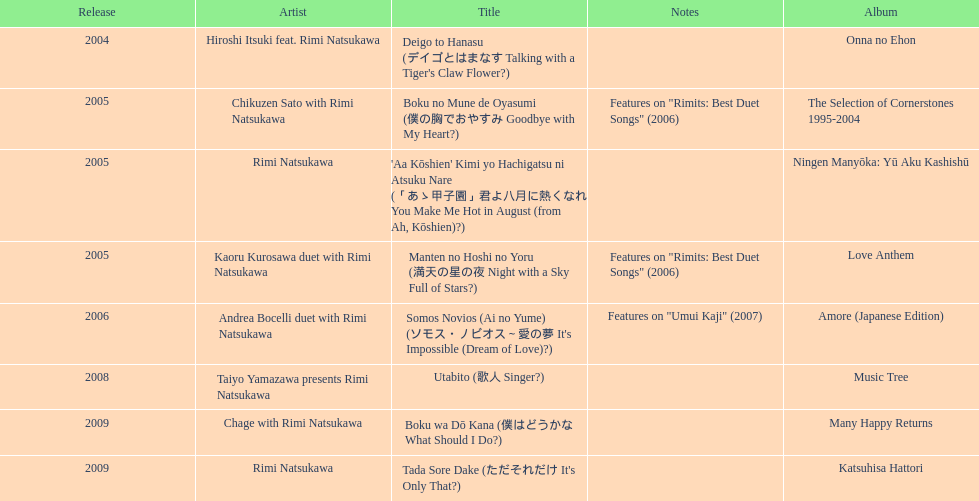Which was not released in 2004, onna no ehon or music tree? Music Tree. Give me the full table as a dictionary. {'header': ['Release', 'Artist', 'Title', 'Notes', 'Album'], 'rows': [['2004', 'Hiroshi Itsuki feat. Rimi Natsukawa', "Deigo to Hanasu (デイゴとはまなす Talking with a Tiger's Claw Flower?)", '', 'Onna no Ehon'], ['2005', 'Chikuzen Sato with Rimi Natsukawa', 'Boku no Mune de Oyasumi (僕の胸でおやすみ Goodbye with My Heart?)', 'Features on "Rimits: Best Duet Songs" (2006)', 'The Selection of Cornerstones 1995-2004'], ['2005', 'Rimi Natsukawa', "'Aa Kōshien' Kimi yo Hachigatsu ni Atsuku Nare (「あゝ甲子園」君よ八月に熱くなれ You Make Me Hot in August (from Ah, Kōshien)?)", '', 'Ningen Manyōka: Yū Aku Kashishū'], ['2005', 'Kaoru Kurosawa duet with Rimi Natsukawa', 'Manten no Hoshi no Yoru (満天の星の夜 Night with a Sky Full of Stars?)', 'Features on "Rimits: Best Duet Songs" (2006)', 'Love Anthem'], ['2006', 'Andrea Bocelli duet with Rimi Natsukawa', "Somos Novios (Ai no Yume) (ソモス・ノビオス～愛の夢 It's Impossible (Dream of Love)?)", 'Features on "Umui Kaji" (2007)', 'Amore (Japanese Edition)'], ['2008', 'Taiyo Yamazawa presents Rimi Natsukawa', 'Utabito (歌人 Singer?)', '', 'Music Tree'], ['2009', 'Chage with Rimi Natsukawa', 'Boku wa Dō Kana (僕はどうかな What Should I Do?)', '', 'Many Happy Returns'], ['2009', 'Rimi Natsukawa', "Tada Sore Dake (ただそれだけ It's Only That?)", '', 'Katsuhisa Hattori']]} 